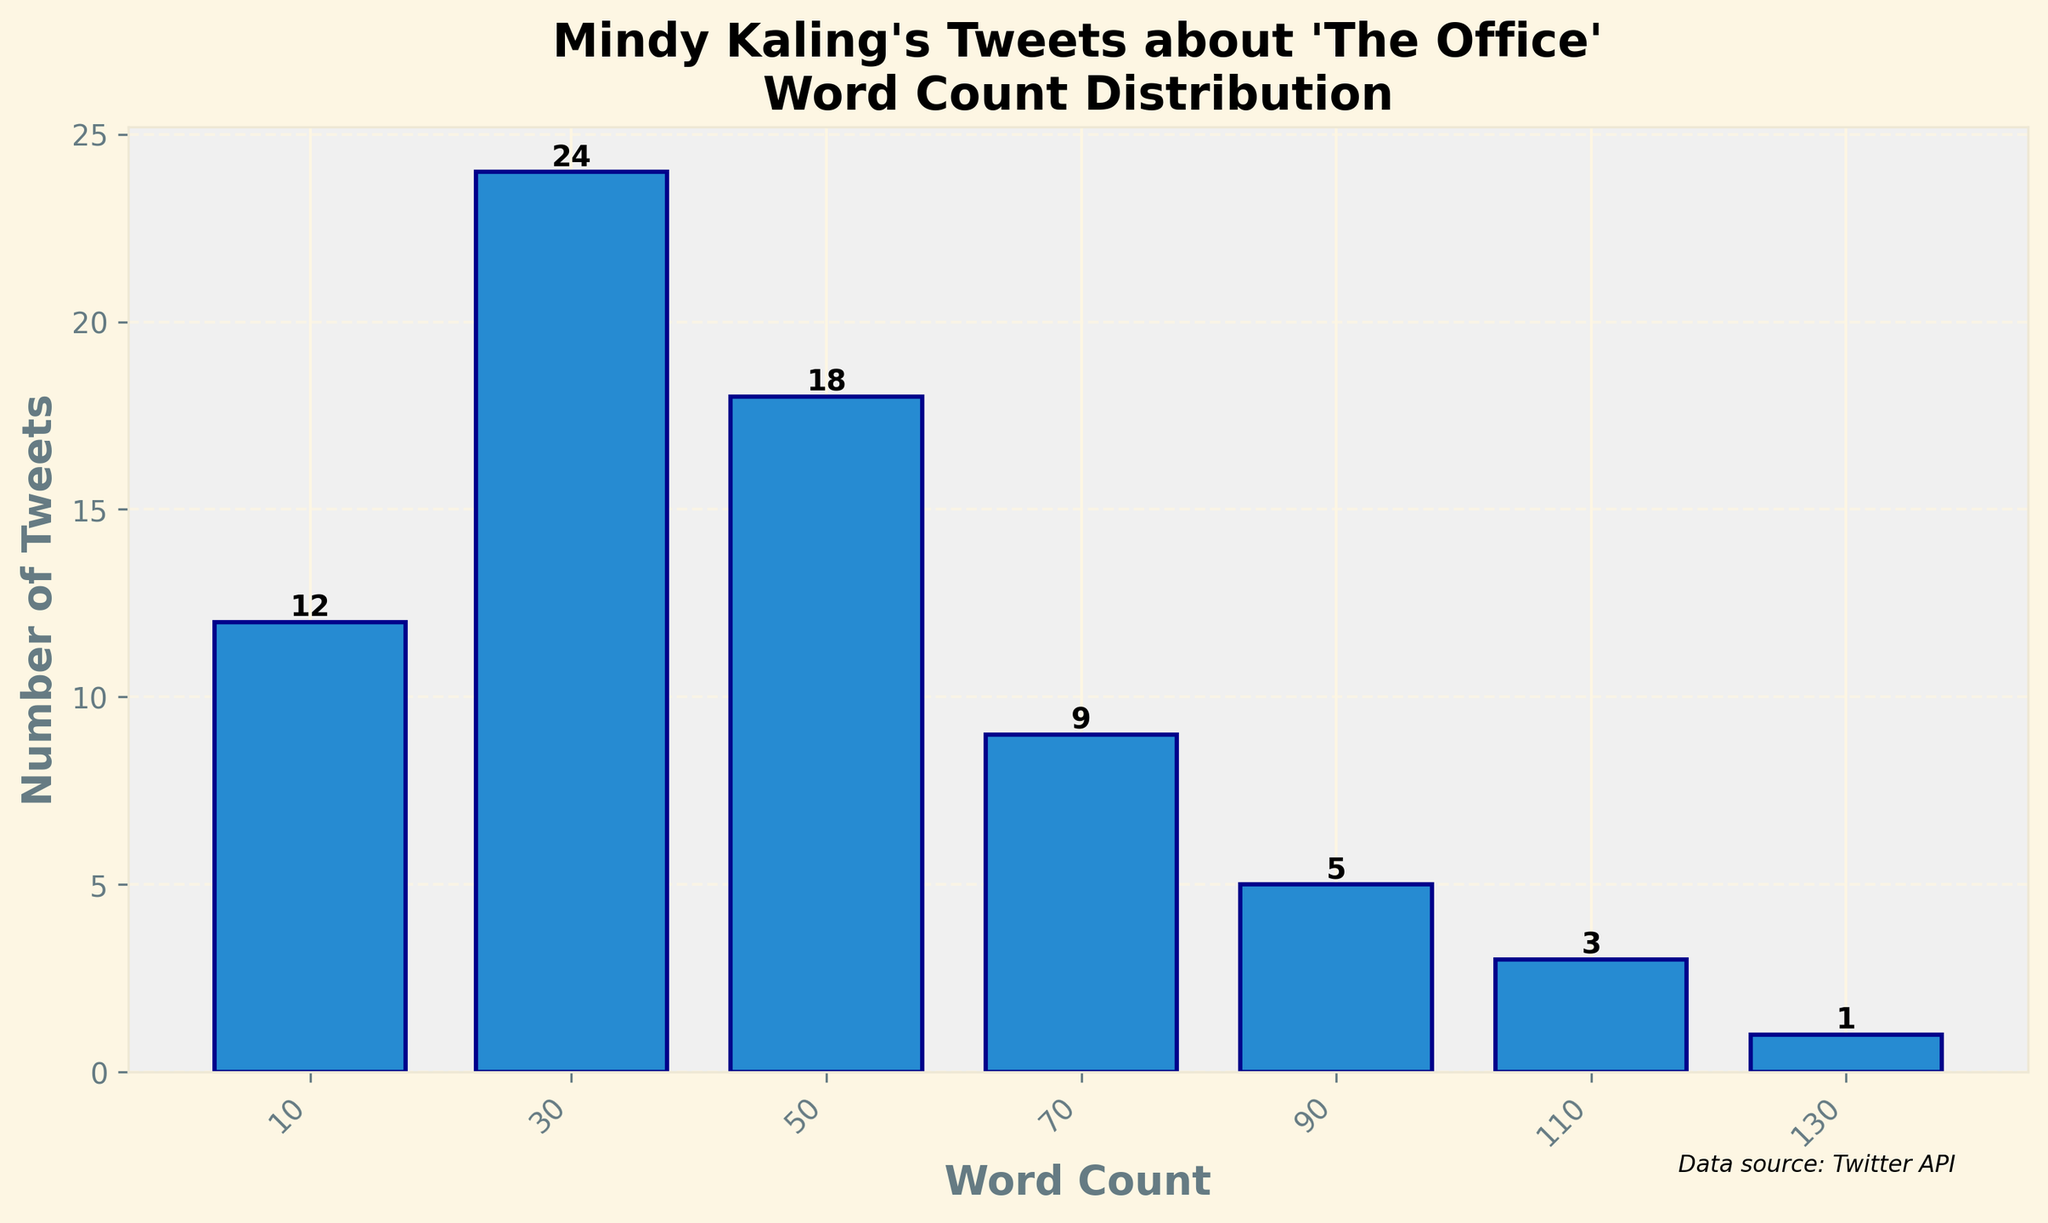What is the title of the plot? The title can be found at the top of the plot. It reads "Mindy Kaling's Tweets about 'The Office'\nWord Count Distribution".
Answer: "Mindy Kaling's Tweets about 'The Office'\nWord Count Distribution" How many tweets fall within the word count range of 41-60? Look for the bar corresponding to the word count range 41-60. The height of the bar is labeled with the number 18.
Answer: 18 Which word count range has the highest number of tweets? Identify the tallest bar in the histogram. The bar for the word count range 21-40 is the tallest, indicating it has the highest number of tweets.
Answer: 21-40 How many tweets are there in total? Sum the number of tweets across all word count ranges: 12 + 24 + 18 + 9 + 5 + 3 + 1 = 72.
Answer: 72 What is the average number of tweets per word count range? There are 7 word count ranges. The total number of tweets is 72. Divide the total number by the number of ranges: 72 / 7 = 10.3.
Answer: 10.3 Which word count range has the least number of tweets? Identify the shortest bar in the histogram. The bar for the word count range 121-140 is the shortest, indicating it has the least number of tweets.
Answer: 121-140 What's the difference in the number of tweets between the most and the least frequent word count ranges? The most frequent word count range (21-40) has 24 tweets and the least frequent (121-140) has 1 tweet. The difference is 24 - 1 = 23.
Answer: 23 Is the number of tweets more or fewer in the range 61-80 compared to the range 81-100? Compare the heights of the bars for the ranges 61-80 and 81-100. The range 61-80 has 9 tweets, and the range 81-100 has 5 tweets, so 61-80 has more.
Answer: More What is the total number of tweets for word count ranges exceeding 60 words? Sum the number of tweets for ranges 61-80, 81-100, 101-120, and 121-140: 9 + 5 + 3 + 1 = 18.
Answer: 18 How many tweets fall within the shortest word count range (0-20)? Look at the bar for the word count range 0-20. The height of the bar is labeled with the number 12.
Answer: 12 